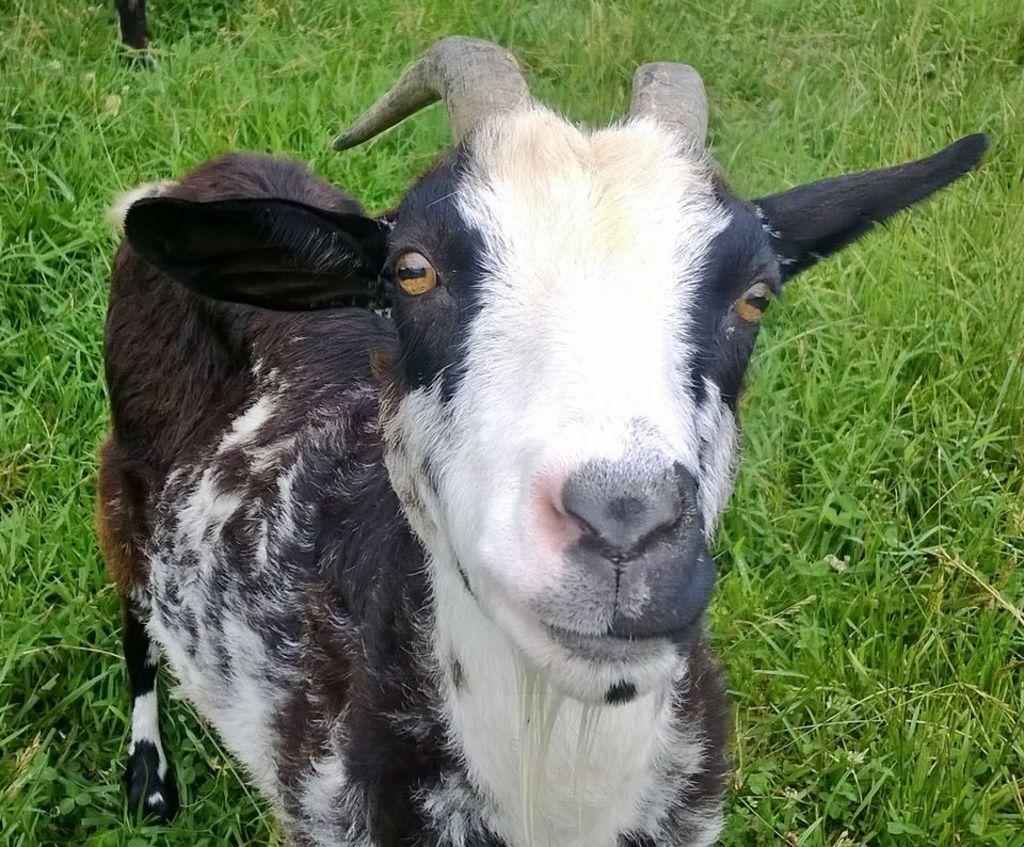How would you summarize this image in a sentence or two? In this image there is a goat standing on the ground. On the ground there is grass. 